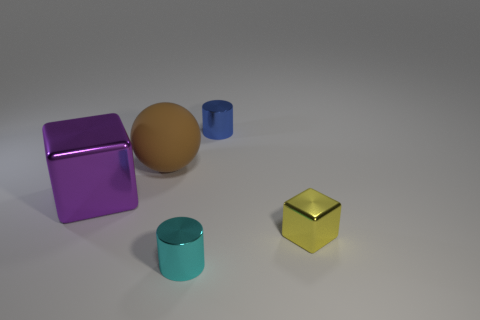Are there any other things that have the same material as the brown ball?
Provide a succinct answer. No. There is a metal thing that is behind the big brown object; what is its shape?
Offer a terse response. Cylinder. Is the thing to the left of the big rubber object made of the same material as the small cylinder in front of the large rubber object?
Provide a short and direct response. Yes. What shape is the tiny yellow metal thing?
Offer a very short reply. Cube. Are there the same number of cyan shiny cylinders that are on the right side of the tiny cyan cylinder and large yellow rubber balls?
Offer a terse response. Yes. Is there a cyan thing made of the same material as the large brown object?
Give a very brief answer. No. There is a tiny thing that is behind the small yellow metallic cube; is it the same shape as the tiny metallic object that is in front of the yellow cube?
Keep it short and to the point. Yes. Are any purple rubber cubes visible?
Your response must be concise. No. The cylinder that is the same size as the cyan object is what color?
Keep it short and to the point. Blue. How many other tiny shiny things are the same shape as the blue object?
Your answer should be compact. 1. 